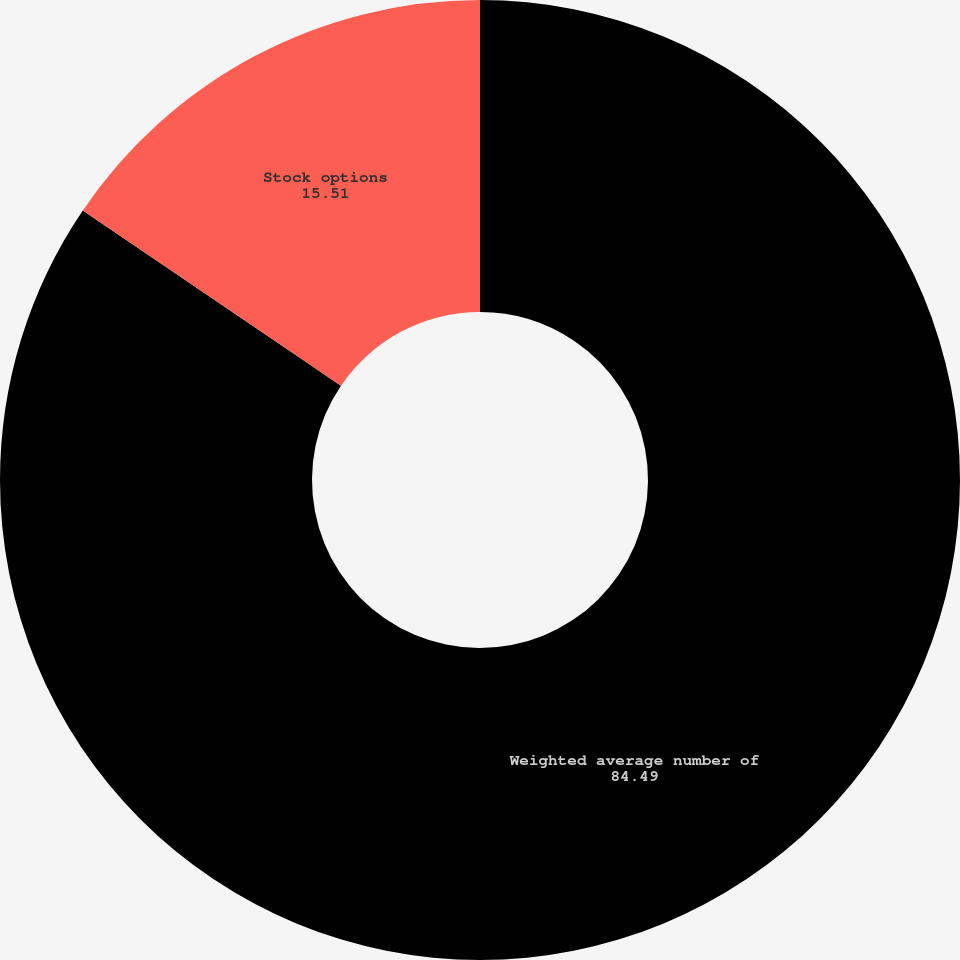Convert chart to OTSL. <chart><loc_0><loc_0><loc_500><loc_500><pie_chart><fcel>Weighted average number of<fcel>Stock options<nl><fcel>84.49%<fcel>15.51%<nl></chart> 